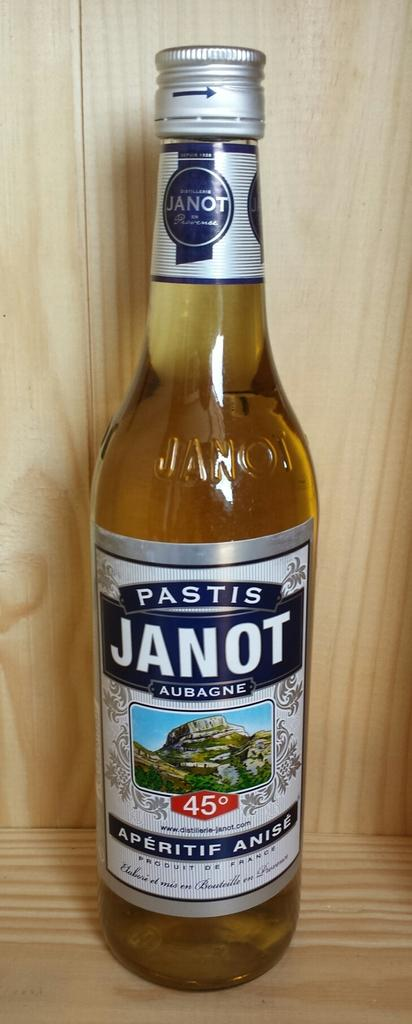<image>
Offer a succinct explanation of the picture presented. An unopened bottle of Pastis Janot on a wooden shelf 